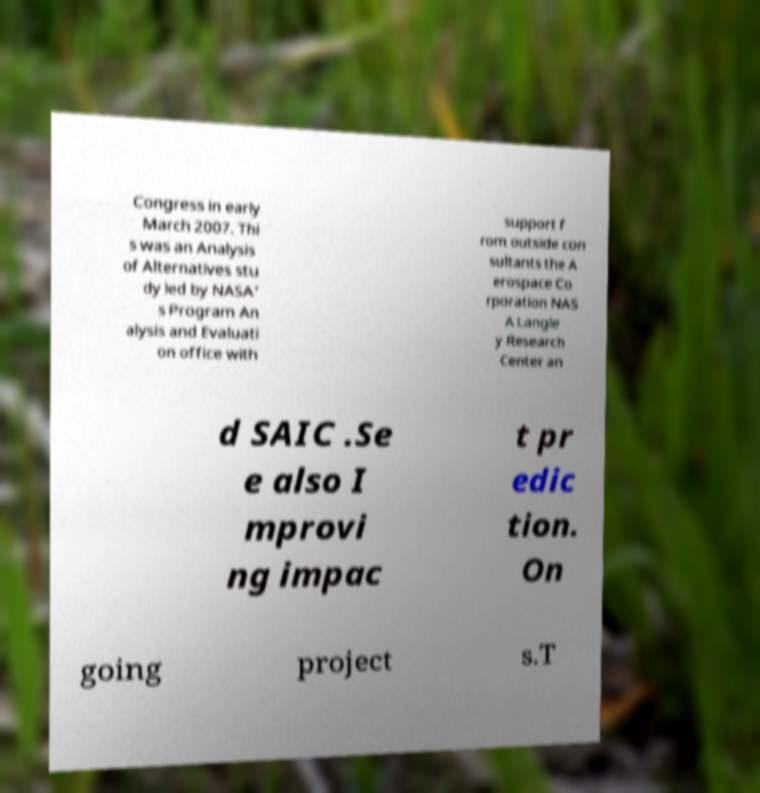Can you accurately transcribe the text from the provided image for me? Congress in early March 2007. Thi s was an Analysis of Alternatives stu dy led by NASA' s Program An alysis and Evaluati on office with support f rom outside con sultants the A erospace Co rporation NAS A Langle y Research Center an d SAIC .Se e also I mprovi ng impac t pr edic tion. On going project s.T 